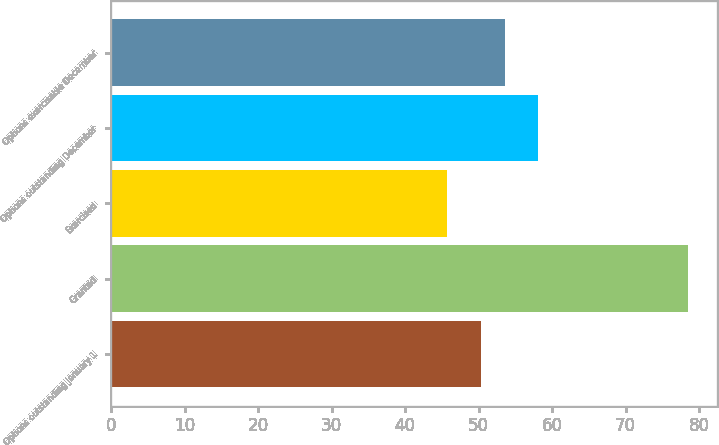Convert chart. <chart><loc_0><loc_0><loc_500><loc_500><bar_chart><fcel>Options outstanding January 1<fcel>Granted<fcel>Exercised<fcel>Options outstanding December<fcel>Options exercisable December<nl><fcel>50.3<fcel>78.54<fcel>45.76<fcel>58.02<fcel>53.58<nl></chart> 